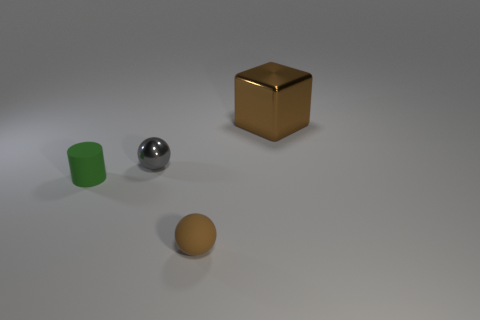Add 1 brown spheres. How many objects exist? 5 Subtract all cylinders. How many objects are left? 3 Add 2 small objects. How many small objects are left? 5 Add 4 tiny brown rubber objects. How many tiny brown rubber objects exist? 5 Subtract 0 purple cylinders. How many objects are left? 4 Subtract all gray objects. Subtract all tiny brown balls. How many objects are left? 2 